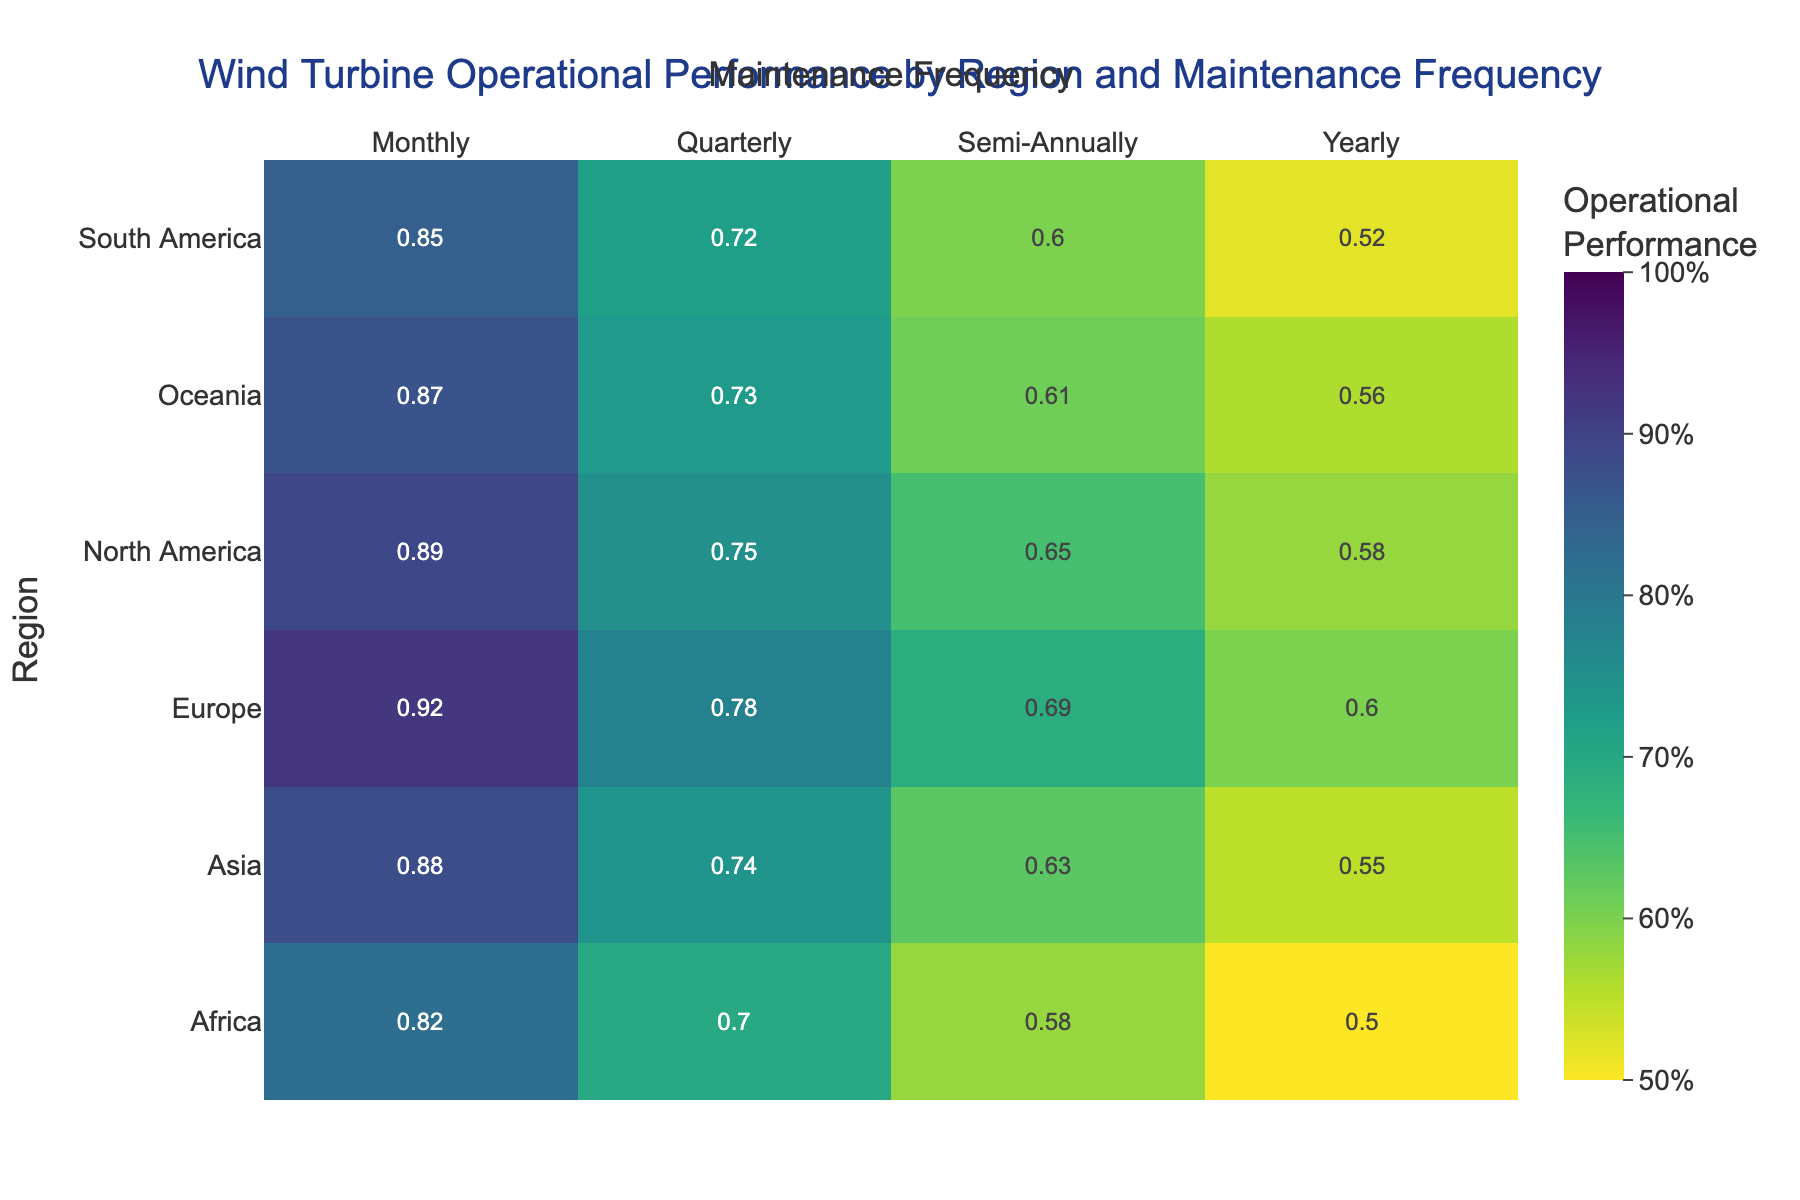What's the title of the heatmap? Look at the top of the plot where the title is displayed, usually centered.
Answer: Wind Turbine Operational Performance by Region and Maintenance Frequency What are the axes titles? Check the labels on the x-axis and y-axis outside the heatmap.
Answer: Maintenance Frequency and Region Which region has the highest operational performance for monthly maintenance frequency? Locate the column for "Monthly" maintenance frequency and identify the highest value across all regions.
Answer: Europe Which region has the lowest operational performance for yearly maintenance frequency? Locate the column for "Yearly" maintenance frequency and identify the lowest value across all regions.
Answer: Africa Compare the operational performance of Europe with North America for quarterly maintenance. Find the values for Europe and North America in the "Quarterly" column, then compare them.
Answer: Europe has higher performance Is the operational performance for semi-annual maintenance frequency higher in Asia or South America? Find the values for Asia and South America in the "Semi-Annually" column and compare them.
Answer: Asia What is the range of operational performance values in North America? Identify the minimum and maximum values in the "North America" row, then compute the range (max-min).
Answer: 0.31 Which maintenance frequency generally shows the highest operational performance across all regions? Scan each row to find the highest value in each row, then determine the maintenance frequency for these high values.
Answer: Monthly Calculate the average operational performance for Oceania across all maintenance frequencies. Add the values for Oceania across all columns and divide by the number of values. (0.87 + 0.73 + 0.61 + 0.56) / 4
Answer: 0.69 